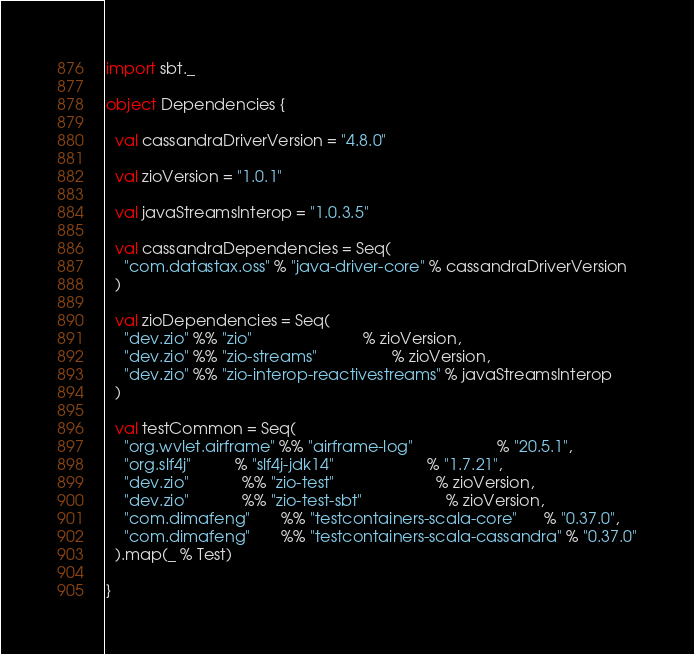Convert code to text. <code><loc_0><loc_0><loc_500><loc_500><_Scala_>import sbt._

object Dependencies {

  val cassandraDriverVersion = "4.8.0"

  val zioVersion = "1.0.1"

  val javaStreamsInterop = "1.0.3.5"

  val cassandraDependencies = Seq(
    "com.datastax.oss" % "java-driver-core" % cassandraDriverVersion
  )

  val zioDependencies = Seq(
    "dev.zio" %% "zio"                         % zioVersion,
    "dev.zio" %% "zio-streams"                 % zioVersion,
    "dev.zio" %% "zio-interop-reactivestreams" % javaStreamsInterop
  )

  val testCommon = Seq(
    "org.wvlet.airframe" %% "airframe-log"                   % "20.5.1",
    "org.slf4j"          % "slf4j-jdk14"                     % "1.7.21",
    "dev.zio"            %% "zio-test"                       % zioVersion,
    "dev.zio"            %% "zio-test-sbt"                   % zioVersion,
    "com.dimafeng"       %% "testcontainers-scala-core"      % "0.37.0",
    "com.dimafeng"       %% "testcontainers-scala-cassandra" % "0.37.0"
  ).map(_ % Test)

}
</code> 